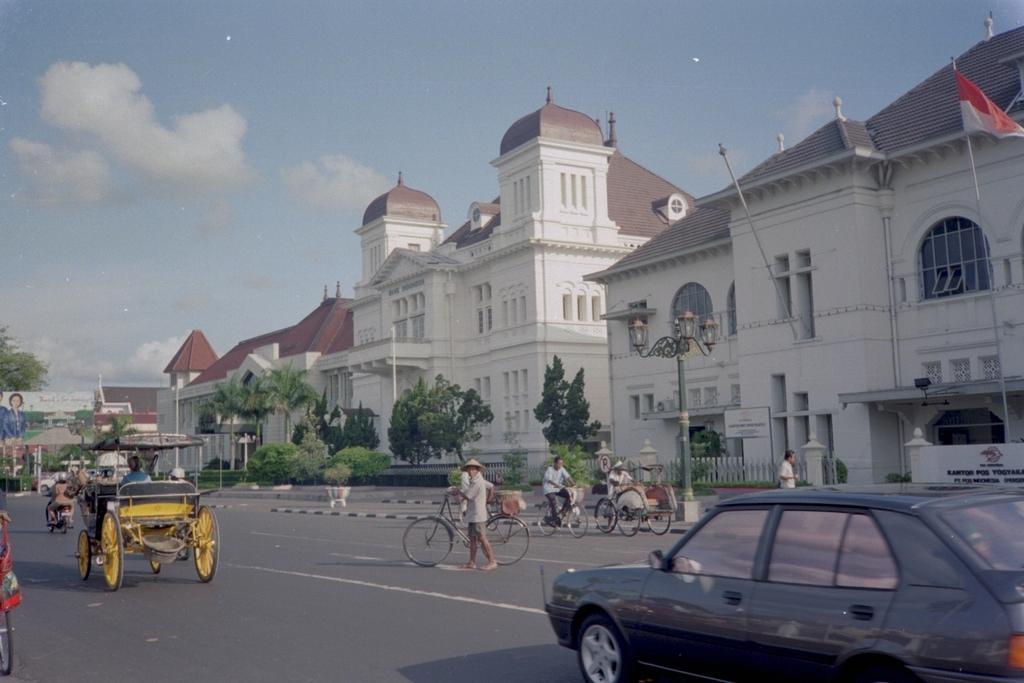Please provide a concise description of this image. On the right side a car is moving on the road, in the middle a person is crossing the road with the cycle, there are buildings and trees in this. On the left side a cart is moving on the road. At the top it is the sky. 